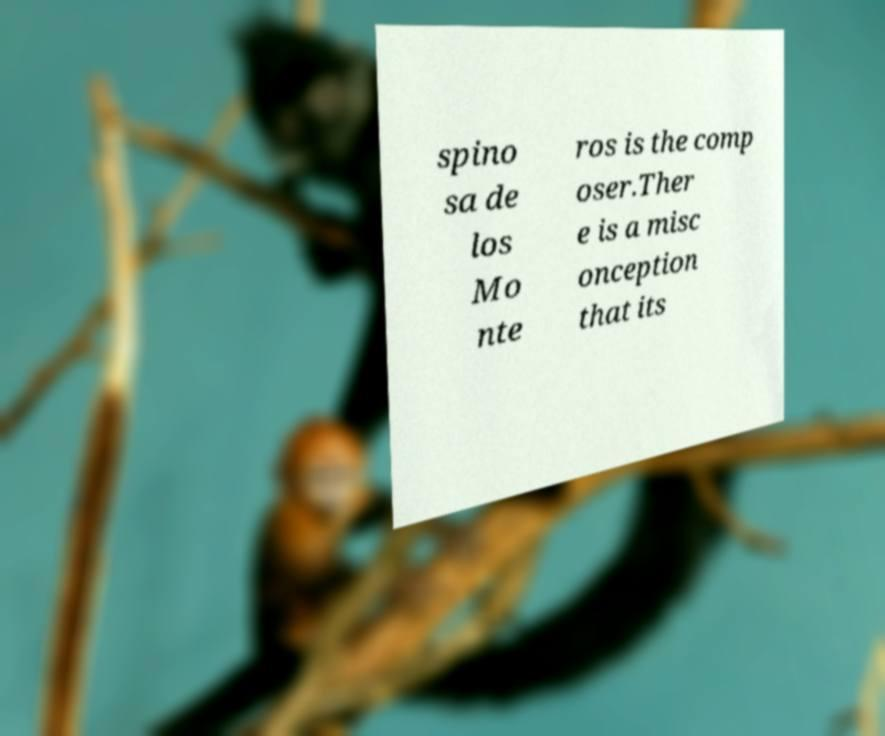I need the written content from this picture converted into text. Can you do that? spino sa de los Mo nte ros is the comp oser.Ther e is a misc onception that its 